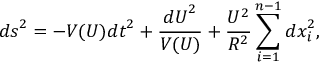<formula> <loc_0><loc_0><loc_500><loc_500>{ d s } ^ { 2 } = - V ( U ) { d t } ^ { 2 } + \frac { { d U } ^ { 2 } } { V ( U ) } + \frac { U ^ { 2 } } { R ^ { 2 } } \sum _ { i = 1 } ^ { n - 1 } { d x } _ { i } ^ { 2 } ,</formula> 